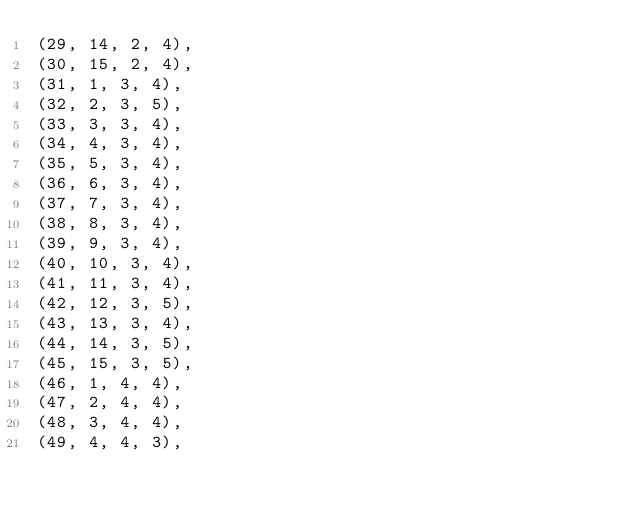Convert code to text. <code><loc_0><loc_0><loc_500><loc_500><_SQL_>(29, 14, 2, 4),
(30, 15, 2, 4),
(31, 1, 3, 4),
(32, 2, 3, 5),
(33, 3, 3, 4),
(34, 4, 3, 4),
(35, 5, 3, 4),
(36, 6, 3, 4),
(37, 7, 3, 4),
(38, 8, 3, 4),
(39, 9, 3, 4),
(40, 10, 3, 4),
(41, 11, 3, 4),
(42, 12, 3, 5),
(43, 13, 3, 4),
(44, 14, 3, 5),
(45, 15, 3, 5),
(46, 1, 4, 4),
(47, 2, 4, 4),
(48, 3, 4, 4),
(49, 4, 4, 3),</code> 